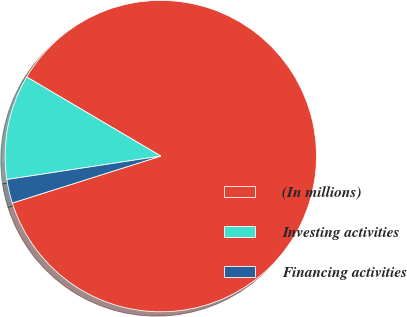<chart> <loc_0><loc_0><loc_500><loc_500><pie_chart><fcel>(In millions)<fcel>Investing activities<fcel>Financing activities<nl><fcel>86.64%<fcel>10.89%<fcel>2.47%<nl></chart> 